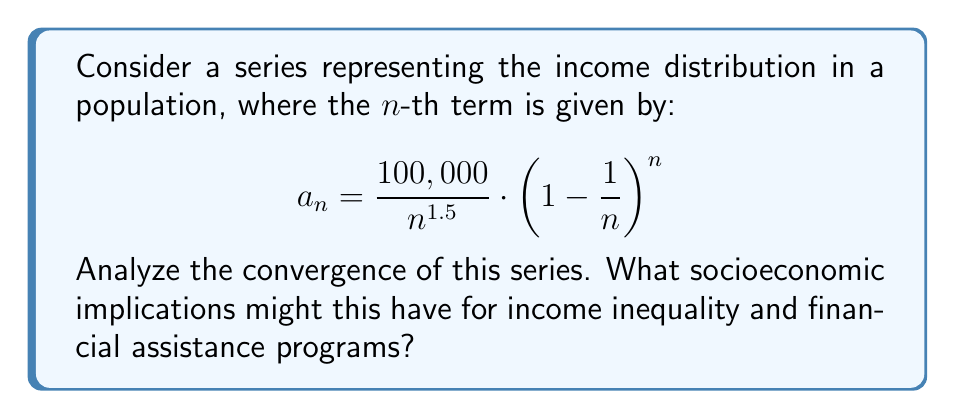Can you solve this math problem? To analyze the convergence of this series, we'll use the limit comparison test with a known series. Let's break this down step-by-step:

1) First, let's simplify the general term:
   $$a_n = \frac{100,000}{n^{1.5}} \cdot \left(1 - \frac{1}{n}\right)^n$$

2) We know that $\lim_{n \to \infty} \left(1 - \frac{1}{n}\right)^n = \frac{1}{e}$. So for large $n$, we can approximate:
   $$a_n \approx \frac{100,000}{e \cdot n^{1.5}}$$

3) Let's compare this with the p-series $\frac{1}{n^p}$ where $p = 1.5$:
   $$\lim_{n \to \infty} \frac{a_n}{\frac{1}{n^{1.5}}} = \lim_{n \to \infty} \frac{\frac{100,000}{e \cdot n^{1.5}}}{\frac{1}{n^{1.5}}} = \frac{100,000}{e}$$

4) Since this limit exists and is finite (and non-zero), our series converges if and only if the p-series $\sum \frac{1}{n^{1.5}}$ converges.

5) We know that p-series converge for $p > 1$, and $1.5 > 1$, so our series converges.

Socioeconomic implications:

1) The convergence of this series suggests that the total income in the population is finite, despite having infinitely many terms.

2) The rate of decay (n^-1.5) indicates a significant income inequality, with a small number of high earners and a large number of low earners.

3) For financial assistance programs, this implies that resources should be carefully allocated, focusing on the lower end of the income distribution where the majority of the population resides.

4) The factor (1 - 1/n)^n, which approaches 1/e, could represent diminishing returns on income as one moves up the distribution, possibly due to factors like progressive taxation or market saturation.
Answer: The series converges. This implies a finite total income with significant income inequality, suggesting that financial assistance programs should focus on the lower end of the income distribution where most of the population is concentrated. 